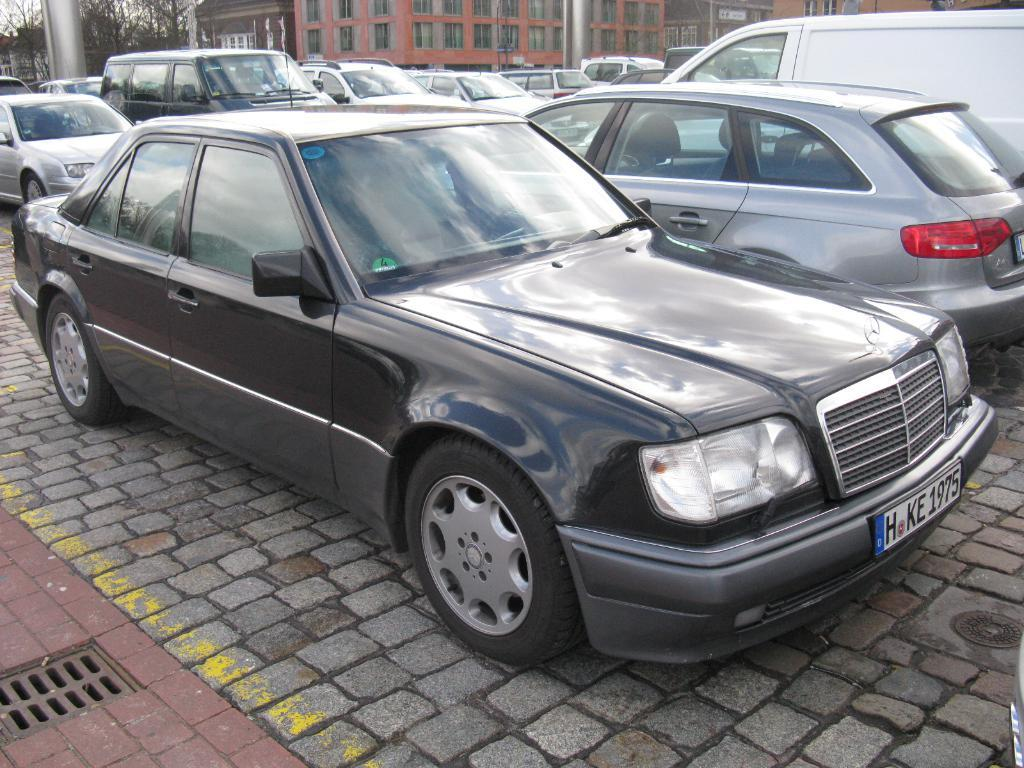What is the main subject in the center of the image? There are cars in the center of the image. What else can be seen in the image besides the cars? There are buildings and trees in the image. Can you describe the object located in the top left side of the image? There is a pole in the top left side of the image. How many cars are crossing the bridge in the image? There is no bridge present in the image; it only features cars, buildings, trees, and a pole. 